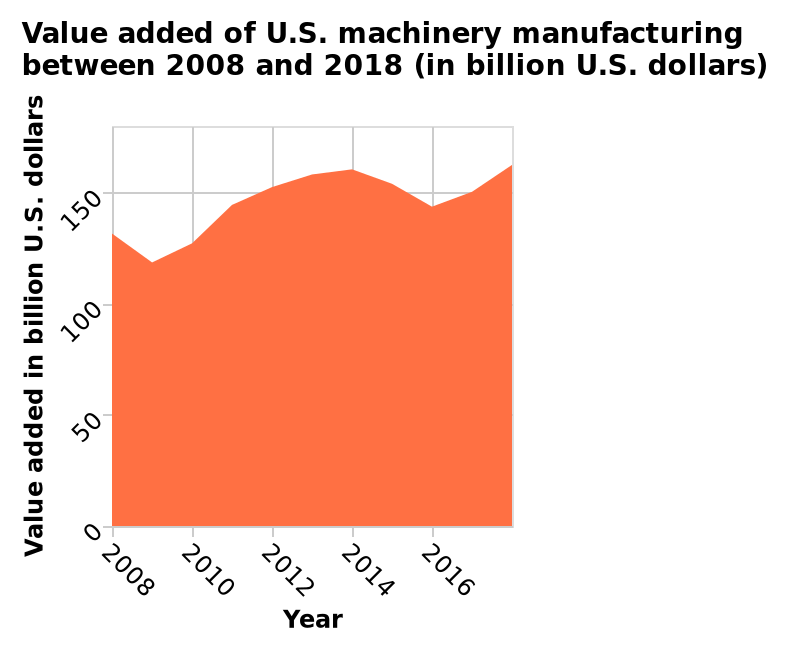<image>
In which unit is the value added data measured in the area diagram? The value added data is measured in "billion U.S. dollars" in the area diagram. How does value added change over time?  Value added increases as time goes on, although there was a slight dip before 2016. Does value added consistently increase over time?  Yes, as time goes on, value added tends to increase. Offer a thorough analysis of the image. The line reaches its lowest value of 115 billion in 2009 and peaks at its highest value of 210 billion in 2014 and again at the end of 2017.there is a steady incline from 2009 to 2014 where it then dips in value but continues to rise afterwards again steadily. 